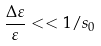Convert formula to latex. <formula><loc_0><loc_0><loc_500><loc_500>\frac { \Delta \varepsilon } \varepsilon < < 1 / s _ { 0 }</formula> 